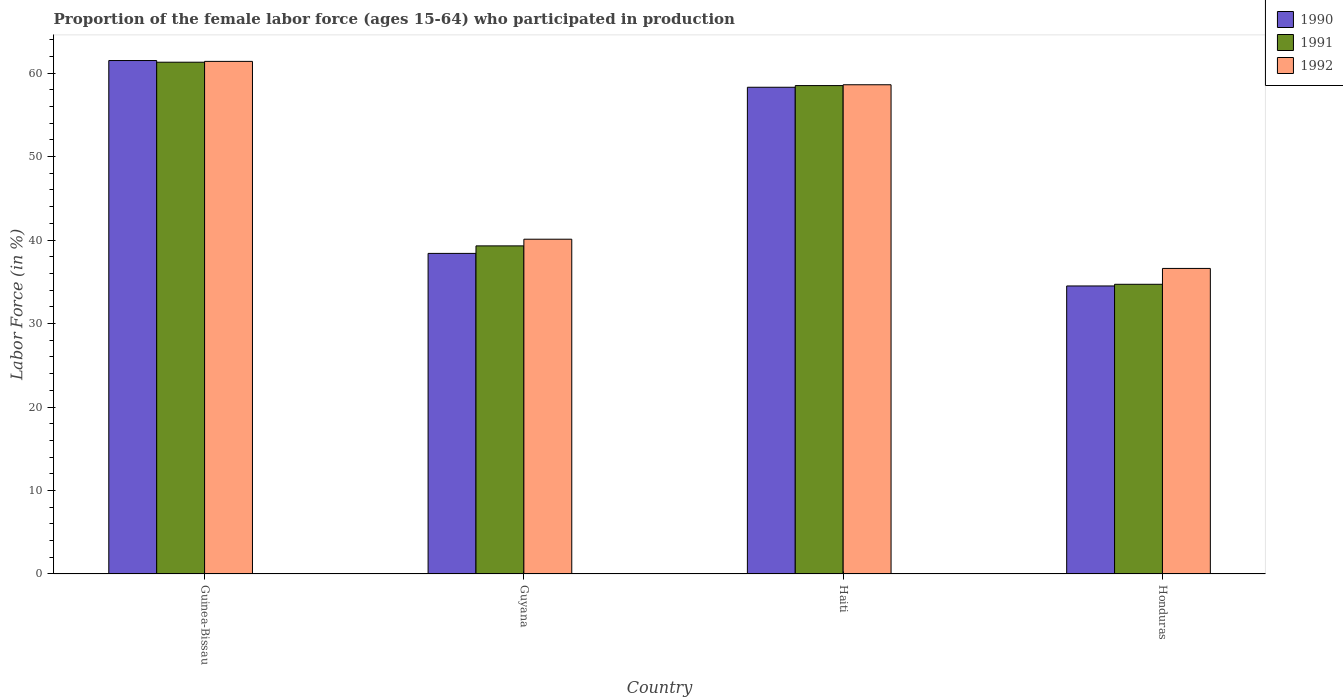How many different coloured bars are there?
Your answer should be compact. 3. How many bars are there on the 3rd tick from the right?
Offer a terse response. 3. What is the label of the 4th group of bars from the left?
Your answer should be very brief. Honduras. In how many cases, is the number of bars for a given country not equal to the number of legend labels?
Your answer should be compact. 0. What is the proportion of the female labor force who participated in production in 1990 in Haiti?
Make the answer very short. 58.3. Across all countries, what is the maximum proportion of the female labor force who participated in production in 1992?
Your answer should be compact. 61.4. Across all countries, what is the minimum proportion of the female labor force who participated in production in 1992?
Ensure brevity in your answer.  36.6. In which country was the proportion of the female labor force who participated in production in 1992 maximum?
Provide a short and direct response. Guinea-Bissau. In which country was the proportion of the female labor force who participated in production in 1992 minimum?
Ensure brevity in your answer.  Honduras. What is the total proportion of the female labor force who participated in production in 1990 in the graph?
Your answer should be very brief. 192.7. What is the difference between the proportion of the female labor force who participated in production in 1990 in Guinea-Bissau and that in Guyana?
Offer a terse response. 23.1. What is the difference between the proportion of the female labor force who participated in production in 1990 in Guyana and the proportion of the female labor force who participated in production in 1992 in Honduras?
Give a very brief answer. 1.8. What is the average proportion of the female labor force who participated in production in 1991 per country?
Offer a very short reply. 48.45. What is the difference between the proportion of the female labor force who participated in production of/in 1991 and proportion of the female labor force who participated in production of/in 1990 in Guyana?
Provide a short and direct response. 0.9. In how many countries, is the proportion of the female labor force who participated in production in 1990 greater than 62 %?
Your answer should be very brief. 0. What is the ratio of the proportion of the female labor force who participated in production in 1990 in Guyana to that in Haiti?
Your response must be concise. 0.66. What is the difference between the highest and the second highest proportion of the female labor force who participated in production in 1991?
Your answer should be very brief. -2.8. What is the difference between the highest and the lowest proportion of the female labor force who participated in production in 1991?
Offer a terse response. 26.6. What does the 3rd bar from the right in Guinea-Bissau represents?
Give a very brief answer. 1990. Is it the case that in every country, the sum of the proportion of the female labor force who participated in production in 1992 and proportion of the female labor force who participated in production in 1990 is greater than the proportion of the female labor force who participated in production in 1991?
Ensure brevity in your answer.  Yes. Are all the bars in the graph horizontal?
Offer a terse response. No. How many countries are there in the graph?
Provide a short and direct response. 4. Does the graph contain any zero values?
Provide a succinct answer. No. Does the graph contain grids?
Your answer should be very brief. No. How are the legend labels stacked?
Provide a short and direct response. Vertical. What is the title of the graph?
Keep it short and to the point. Proportion of the female labor force (ages 15-64) who participated in production. What is the label or title of the X-axis?
Offer a terse response. Country. What is the label or title of the Y-axis?
Make the answer very short. Labor Force (in %). What is the Labor Force (in %) in 1990 in Guinea-Bissau?
Make the answer very short. 61.5. What is the Labor Force (in %) of 1991 in Guinea-Bissau?
Your answer should be compact. 61.3. What is the Labor Force (in %) in 1992 in Guinea-Bissau?
Keep it short and to the point. 61.4. What is the Labor Force (in %) of 1990 in Guyana?
Ensure brevity in your answer.  38.4. What is the Labor Force (in %) in 1991 in Guyana?
Provide a short and direct response. 39.3. What is the Labor Force (in %) of 1992 in Guyana?
Your response must be concise. 40.1. What is the Labor Force (in %) of 1990 in Haiti?
Make the answer very short. 58.3. What is the Labor Force (in %) of 1991 in Haiti?
Keep it short and to the point. 58.5. What is the Labor Force (in %) in 1992 in Haiti?
Offer a terse response. 58.6. What is the Labor Force (in %) of 1990 in Honduras?
Provide a short and direct response. 34.5. What is the Labor Force (in %) in 1991 in Honduras?
Provide a succinct answer. 34.7. What is the Labor Force (in %) in 1992 in Honduras?
Provide a succinct answer. 36.6. Across all countries, what is the maximum Labor Force (in %) in 1990?
Give a very brief answer. 61.5. Across all countries, what is the maximum Labor Force (in %) in 1991?
Offer a very short reply. 61.3. Across all countries, what is the maximum Labor Force (in %) of 1992?
Ensure brevity in your answer.  61.4. Across all countries, what is the minimum Labor Force (in %) of 1990?
Provide a succinct answer. 34.5. Across all countries, what is the minimum Labor Force (in %) in 1991?
Give a very brief answer. 34.7. Across all countries, what is the minimum Labor Force (in %) of 1992?
Give a very brief answer. 36.6. What is the total Labor Force (in %) of 1990 in the graph?
Make the answer very short. 192.7. What is the total Labor Force (in %) of 1991 in the graph?
Provide a succinct answer. 193.8. What is the total Labor Force (in %) of 1992 in the graph?
Your answer should be compact. 196.7. What is the difference between the Labor Force (in %) in 1990 in Guinea-Bissau and that in Guyana?
Offer a terse response. 23.1. What is the difference between the Labor Force (in %) in 1992 in Guinea-Bissau and that in Guyana?
Provide a short and direct response. 21.3. What is the difference between the Labor Force (in %) in 1991 in Guinea-Bissau and that in Haiti?
Ensure brevity in your answer.  2.8. What is the difference between the Labor Force (in %) of 1991 in Guinea-Bissau and that in Honduras?
Keep it short and to the point. 26.6. What is the difference between the Labor Force (in %) in 1992 in Guinea-Bissau and that in Honduras?
Provide a short and direct response. 24.8. What is the difference between the Labor Force (in %) of 1990 in Guyana and that in Haiti?
Provide a succinct answer. -19.9. What is the difference between the Labor Force (in %) in 1991 in Guyana and that in Haiti?
Make the answer very short. -19.2. What is the difference between the Labor Force (in %) in 1992 in Guyana and that in Haiti?
Provide a short and direct response. -18.5. What is the difference between the Labor Force (in %) of 1991 in Guyana and that in Honduras?
Make the answer very short. 4.6. What is the difference between the Labor Force (in %) of 1990 in Haiti and that in Honduras?
Keep it short and to the point. 23.8. What is the difference between the Labor Force (in %) of 1991 in Haiti and that in Honduras?
Give a very brief answer. 23.8. What is the difference between the Labor Force (in %) in 1990 in Guinea-Bissau and the Labor Force (in %) in 1991 in Guyana?
Your answer should be very brief. 22.2. What is the difference between the Labor Force (in %) in 1990 in Guinea-Bissau and the Labor Force (in %) in 1992 in Guyana?
Ensure brevity in your answer.  21.4. What is the difference between the Labor Force (in %) in 1991 in Guinea-Bissau and the Labor Force (in %) in 1992 in Guyana?
Your answer should be very brief. 21.2. What is the difference between the Labor Force (in %) in 1990 in Guinea-Bissau and the Labor Force (in %) in 1991 in Haiti?
Offer a terse response. 3. What is the difference between the Labor Force (in %) in 1990 in Guinea-Bissau and the Labor Force (in %) in 1991 in Honduras?
Offer a very short reply. 26.8. What is the difference between the Labor Force (in %) of 1990 in Guinea-Bissau and the Labor Force (in %) of 1992 in Honduras?
Offer a very short reply. 24.9. What is the difference between the Labor Force (in %) of 1991 in Guinea-Bissau and the Labor Force (in %) of 1992 in Honduras?
Ensure brevity in your answer.  24.7. What is the difference between the Labor Force (in %) of 1990 in Guyana and the Labor Force (in %) of 1991 in Haiti?
Ensure brevity in your answer.  -20.1. What is the difference between the Labor Force (in %) of 1990 in Guyana and the Labor Force (in %) of 1992 in Haiti?
Your answer should be compact. -20.2. What is the difference between the Labor Force (in %) in 1991 in Guyana and the Labor Force (in %) in 1992 in Haiti?
Make the answer very short. -19.3. What is the difference between the Labor Force (in %) of 1990 in Guyana and the Labor Force (in %) of 1992 in Honduras?
Provide a succinct answer. 1.8. What is the difference between the Labor Force (in %) in 1991 in Guyana and the Labor Force (in %) in 1992 in Honduras?
Give a very brief answer. 2.7. What is the difference between the Labor Force (in %) in 1990 in Haiti and the Labor Force (in %) in 1991 in Honduras?
Your response must be concise. 23.6. What is the difference between the Labor Force (in %) of 1990 in Haiti and the Labor Force (in %) of 1992 in Honduras?
Offer a terse response. 21.7. What is the difference between the Labor Force (in %) of 1991 in Haiti and the Labor Force (in %) of 1992 in Honduras?
Give a very brief answer. 21.9. What is the average Labor Force (in %) of 1990 per country?
Your answer should be compact. 48.17. What is the average Labor Force (in %) in 1991 per country?
Ensure brevity in your answer.  48.45. What is the average Labor Force (in %) of 1992 per country?
Make the answer very short. 49.17. What is the difference between the Labor Force (in %) in 1991 and Labor Force (in %) in 1992 in Guyana?
Offer a very short reply. -0.8. What is the difference between the Labor Force (in %) in 1990 and Labor Force (in %) in 1992 in Haiti?
Ensure brevity in your answer.  -0.3. What is the difference between the Labor Force (in %) in 1990 and Labor Force (in %) in 1992 in Honduras?
Your response must be concise. -2.1. What is the difference between the Labor Force (in %) of 1991 and Labor Force (in %) of 1992 in Honduras?
Your answer should be compact. -1.9. What is the ratio of the Labor Force (in %) in 1990 in Guinea-Bissau to that in Guyana?
Give a very brief answer. 1.6. What is the ratio of the Labor Force (in %) in 1991 in Guinea-Bissau to that in Guyana?
Your response must be concise. 1.56. What is the ratio of the Labor Force (in %) in 1992 in Guinea-Bissau to that in Guyana?
Give a very brief answer. 1.53. What is the ratio of the Labor Force (in %) in 1990 in Guinea-Bissau to that in Haiti?
Provide a succinct answer. 1.05. What is the ratio of the Labor Force (in %) of 1991 in Guinea-Bissau to that in Haiti?
Offer a very short reply. 1.05. What is the ratio of the Labor Force (in %) of 1992 in Guinea-Bissau to that in Haiti?
Your answer should be compact. 1.05. What is the ratio of the Labor Force (in %) in 1990 in Guinea-Bissau to that in Honduras?
Your answer should be very brief. 1.78. What is the ratio of the Labor Force (in %) of 1991 in Guinea-Bissau to that in Honduras?
Ensure brevity in your answer.  1.77. What is the ratio of the Labor Force (in %) of 1992 in Guinea-Bissau to that in Honduras?
Provide a succinct answer. 1.68. What is the ratio of the Labor Force (in %) of 1990 in Guyana to that in Haiti?
Provide a short and direct response. 0.66. What is the ratio of the Labor Force (in %) in 1991 in Guyana to that in Haiti?
Provide a short and direct response. 0.67. What is the ratio of the Labor Force (in %) in 1992 in Guyana to that in Haiti?
Offer a terse response. 0.68. What is the ratio of the Labor Force (in %) in 1990 in Guyana to that in Honduras?
Your answer should be very brief. 1.11. What is the ratio of the Labor Force (in %) of 1991 in Guyana to that in Honduras?
Offer a very short reply. 1.13. What is the ratio of the Labor Force (in %) in 1992 in Guyana to that in Honduras?
Your answer should be compact. 1.1. What is the ratio of the Labor Force (in %) of 1990 in Haiti to that in Honduras?
Provide a short and direct response. 1.69. What is the ratio of the Labor Force (in %) in 1991 in Haiti to that in Honduras?
Your answer should be compact. 1.69. What is the ratio of the Labor Force (in %) in 1992 in Haiti to that in Honduras?
Your response must be concise. 1.6. What is the difference between the highest and the second highest Labor Force (in %) of 1991?
Ensure brevity in your answer.  2.8. What is the difference between the highest and the lowest Labor Force (in %) in 1990?
Give a very brief answer. 27. What is the difference between the highest and the lowest Labor Force (in %) in 1991?
Offer a terse response. 26.6. What is the difference between the highest and the lowest Labor Force (in %) in 1992?
Your answer should be compact. 24.8. 